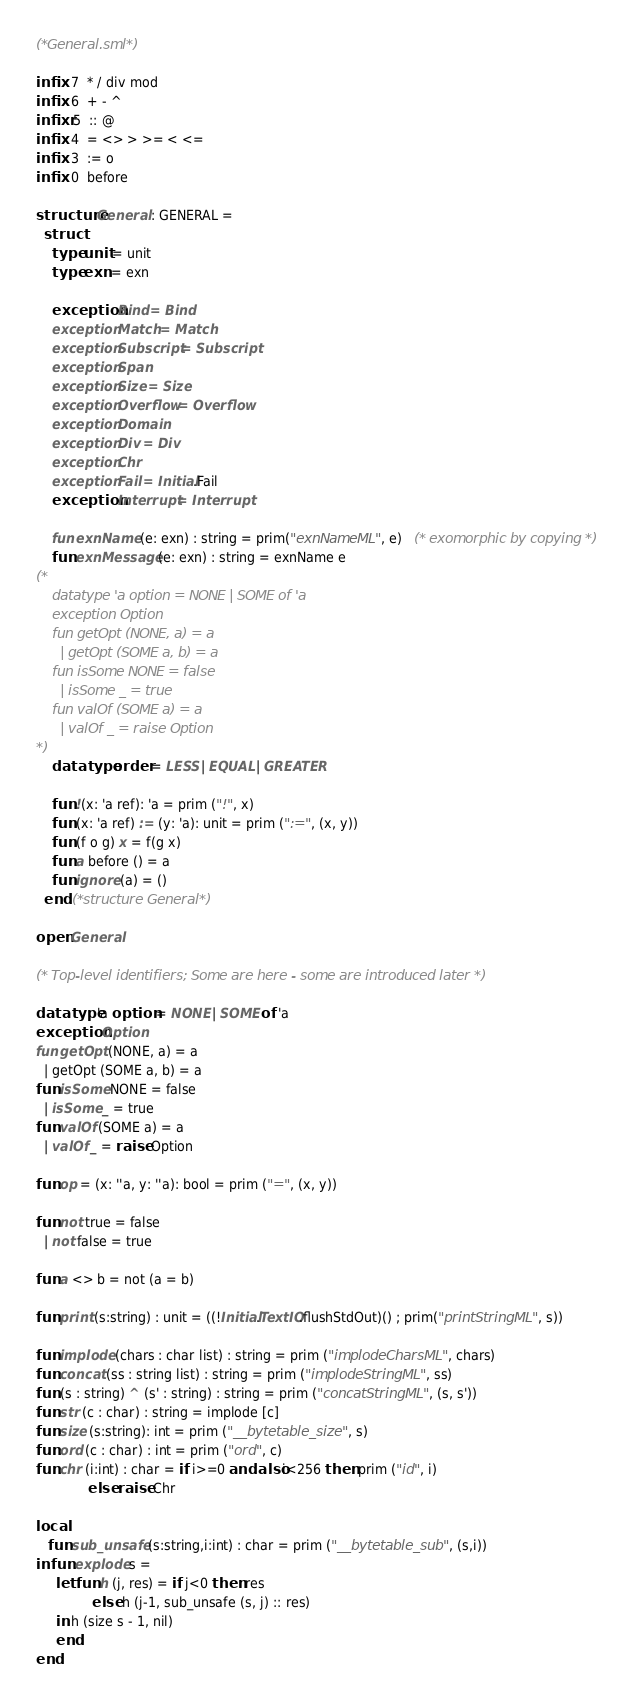Convert code to text. <code><loc_0><loc_0><loc_500><loc_500><_SML_>(*General.sml*)

infix  7  * / div mod
infix  6  + - ^
infixr 5  :: @
infix  4  = <> > >= < <=
infix  3  := o
infix  0  before

structure General : GENERAL =
  struct
    type unit = unit
    type exn = exn

    exception Bind = Bind
    exception Match = Match
    exception Subscript = Subscript
    exception Span
    exception Size = Size
    exception Overflow = Overflow
    exception Domain
    exception Div = Div
    exception Chr
    exception Fail = Initial.Fail
    exception Interrupt = Interrupt

    fun exnName (e: exn) : string = prim("exnNameML", e)   (* exomorphic by copying *)
    fun exnMessage (e: exn) : string = exnName e
(*
    datatype 'a option = NONE | SOME of 'a
    exception Option
    fun getOpt (NONE, a) = a
      | getOpt (SOME a, b) = a
    fun isSome NONE = false
      | isSome _ = true
    fun valOf (SOME a) = a
      | valOf _ = raise Option
*)
    datatype order = LESS | EQUAL | GREATER

    fun !(x: 'a ref): 'a = prim ("!", x)
    fun (x: 'a ref) := (y: 'a): unit = prim (":=", (x, y))
    fun (f o g) x = f(g x)
    fun a before () = a
    fun ignore (a) = ()
  end (*structure General*)

open General

(* Top-level identifiers; Some are here - some are introduced later *)

datatype 'a option = NONE | SOME of 'a
exception Option
fun getOpt (NONE, a) = a
  | getOpt (SOME a, b) = a
fun isSome NONE = false
  | isSome _ = true
fun valOf (SOME a) = a
  | valOf _ = raise Option

fun op = (x: ''a, y: ''a): bool = prim ("=", (x, y))

fun not true = false
  | not false = true

fun a <> b = not (a = b)

fun print (s:string) : unit = ((!Initial.TextIO.flushStdOut)() ; prim("printStringML", s))

fun implode (chars : char list) : string = prim ("implodeCharsML", chars)
fun concat (ss : string list) : string = prim ("implodeStringML", ss)
fun (s : string) ^ (s' : string) : string = prim ("concatStringML", (s, s'))
fun str (c : char) : string = implode [c]
fun size (s:string): int = prim ("__bytetable_size", s)
fun ord (c : char) : int = prim ("ord", c)
fun chr (i:int) : char = if i>=0 andalso i<256 then prim ("id", i)
			 else raise Chr

local
   fun sub_unsafe (s:string,i:int) : char = prim ("__bytetable_sub", (s,i))
in fun explode s =
     let fun h (j, res) = if j<0 then res
			  else h (j-1, sub_unsafe (s, j) :: res)
     in h (size s - 1, nil)
     end
end
</code> 